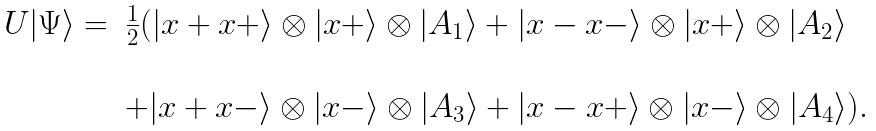<formula> <loc_0><loc_0><loc_500><loc_500>\begin{array} { r l } U | \Psi \rangle = & \frac { 1 } { 2 } ( | x + x + \rangle \otimes | x + \rangle \otimes | A _ { 1 } \rangle + | x - x - \rangle \otimes | x + \rangle \otimes | A _ { 2 } \rangle \\ & \\ & + | x + x - \rangle \otimes | x - \rangle \otimes | A _ { 3 } \rangle + | x - x + \rangle \otimes | x - \rangle \otimes | A _ { 4 } \rangle ) . \end{array}</formula> 